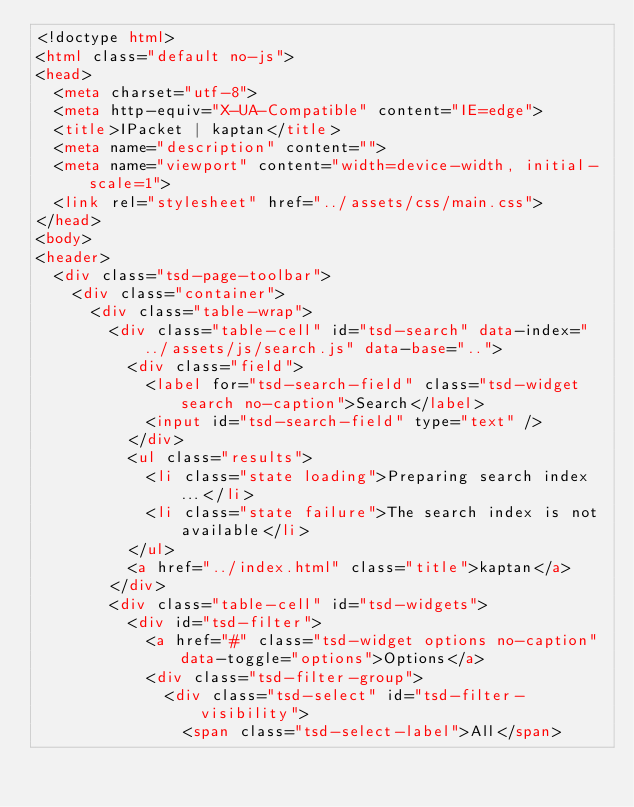<code> <loc_0><loc_0><loc_500><loc_500><_HTML_><!doctype html>
<html class="default no-js">
<head>
	<meta charset="utf-8">
	<meta http-equiv="X-UA-Compatible" content="IE=edge">
	<title>IPacket | kaptan</title>
	<meta name="description" content="">
	<meta name="viewport" content="width=device-width, initial-scale=1">
	<link rel="stylesheet" href="../assets/css/main.css">
</head>
<body>
<header>
	<div class="tsd-page-toolbar">
		<div class="container">
			<div class="table-wrap">
				<div class="table-cell" id="tsd-search" data-index="../assets/js/search.js" data-base="..">
					<div class="field">
						<label for="tsd-search-field" class="tsd-widget search no-caption">Search</label>
						<input id="tsd-search-field" type="text" />
					</div>
					<ul class="results">
						<li class="state loading">Preparing search index...</li>
						<li class="state failure">The search index is not available</li>
					</ul>
					<a href="../index.html" class="title">kaptan</a>
				</div>
				<div class="table-cell" id="tsd-widgets">
					<div id="tsd-filter">
						<a href="#" class="tsd-widget options no-caption" data-toggle="options">Options</a>
						<div class="tsd-filter-group">
							<div class="tsd-select" id="tsd-filter-visibility">
								<span class="tsd-select-label">All</span></code> 